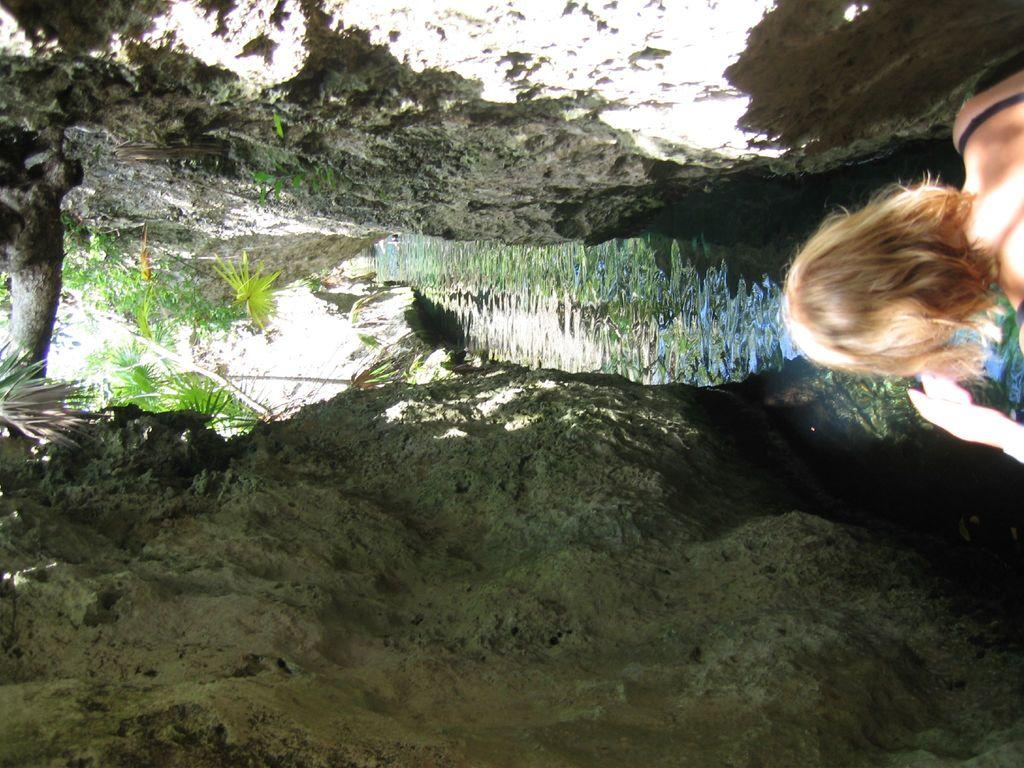What is located on the right side of the image? There is a person on the right side of the image. What can be seen in the middle of the image? There is water, plants, and trees in the middle of the image. What type of natural features are present at the top and bottom of the image? There are rocks at the top and bottom of the image. How many spiders are crawling on the person in the image? There are no spiders visible in the image; it features a person, water, plants, trees, and rocks. What is the slope of the terrain in the image? The image does not depict a slope or any indication of the terrain's inclination. 